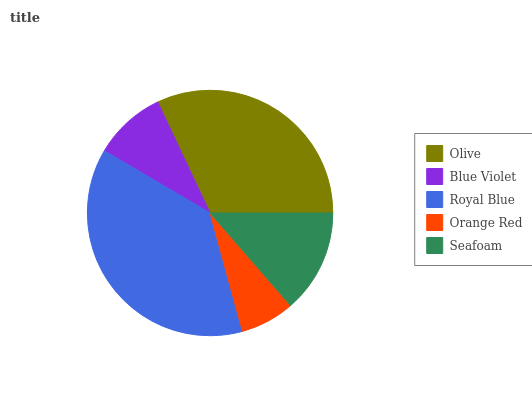Is Orange Red the minimum?
Answer yes or no. Yes. Is Royal Blue the maximum?
Answer yes or no. Yes. Is Blue Violet the minimum?
Answer yes or no. No. Is Blue Violet the maximum?
Answer yes or no. No. Is Olive greater than Blue Violet?
Answer yes or no. Yes. Is Blue Violet less than Olive?
Answer yes or no. Yes. Is Blue Violet greater than Olive?
Answer yes or no. No. Is Olive less than Blue Violet?
Answer yes or no. No. Is Seafoam the high median?
Answer yes or no. Yes. Is Seafoam the low median?
Answer yes or no. Yes. Is Olive the high median?
Answer yes or no. No. Is Olive the low median?
Answer yes or no. No. 